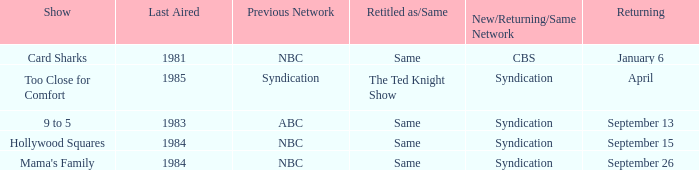What was the initial aired show that's making a return on september 13? 1983.0. 